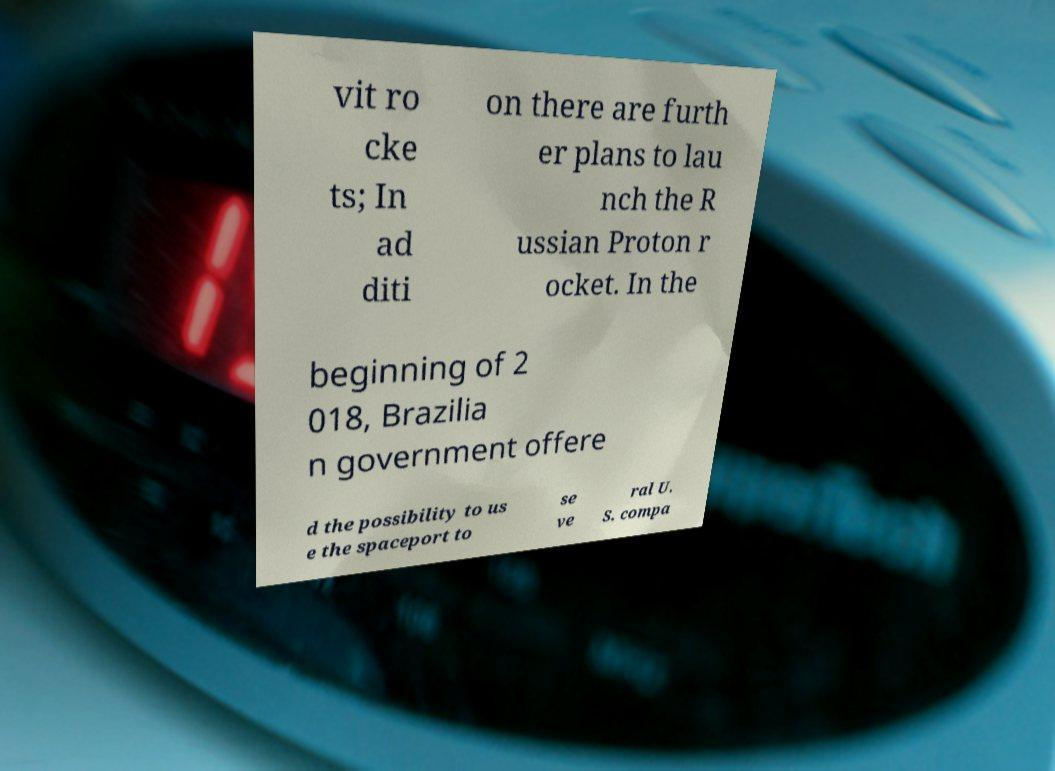Could you assist in decoding the text presented in this image and type it out clearly? vit ro cke ts; In ad diti on there are furth er plans to lau nch the R ussian Proton r ocket. In the beginning of 2 018, Brazilia n government offere d the possibility to us e the spaceport to se ve ral U. S. compa 